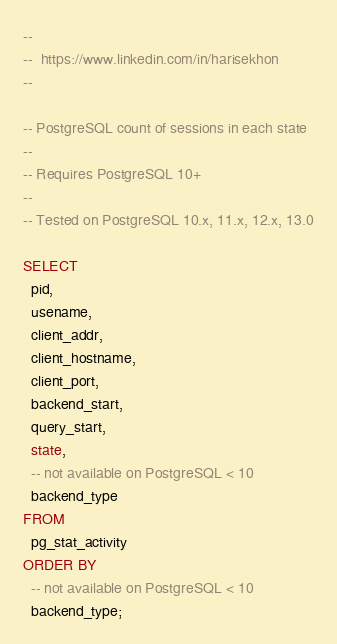Convert code to text. <code><loc_0><loc_0><loc_500><loc_500><_SQL_>--
--  https://www.linkedin.com/in/harisekhon
--

-- PostgreSQL count of sessions in each state
--
-- Requires PostgreSQL 10+
--
-- Tested on PostgreSQL 10.x, 11.x, 12.x, 13.0

SELECT
  pid,
  usename,
  client_addr,
  client_hostname,
  client_port,
  backend_start,
  query_start,
  state,
  -- not available on PostgreSQL < 10
  backend_type
FROM
  pg_stat_activity
ORDER BY
  -- not available on PostgreSQL < 10
  backend_type;
</code> 